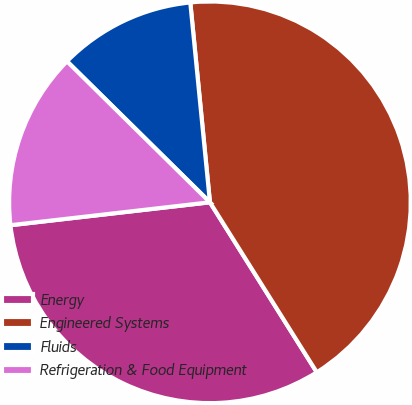<chart> <loc_0><loc_0><loc_500><loc_500><pie_chart><fcel>Energy<fcel>Engineered Systems<fcel>Fluids<fcel>Refrigeration & Food Equipment<nl><fcel>32.11%<fcel>42.63%<fcel>11.05%<fcel>14.21%<nl></chart> 